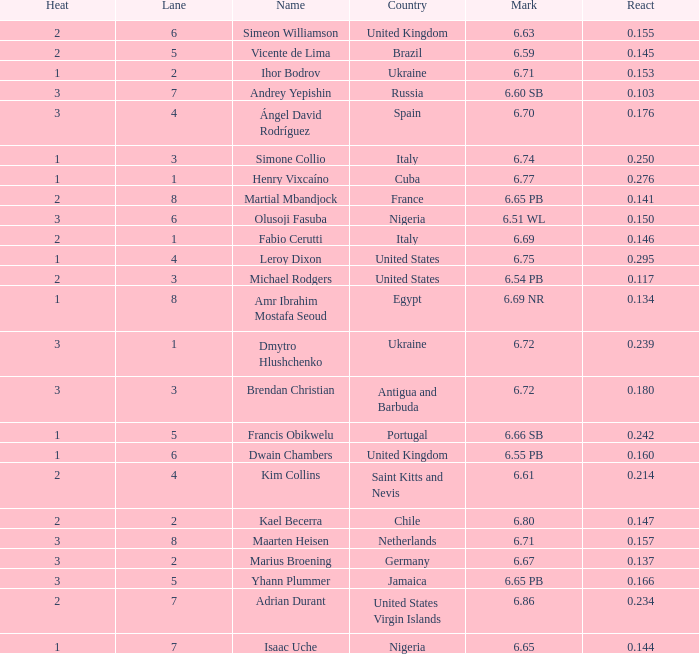What is Heat, when Mark is 6.69? 2.0. 